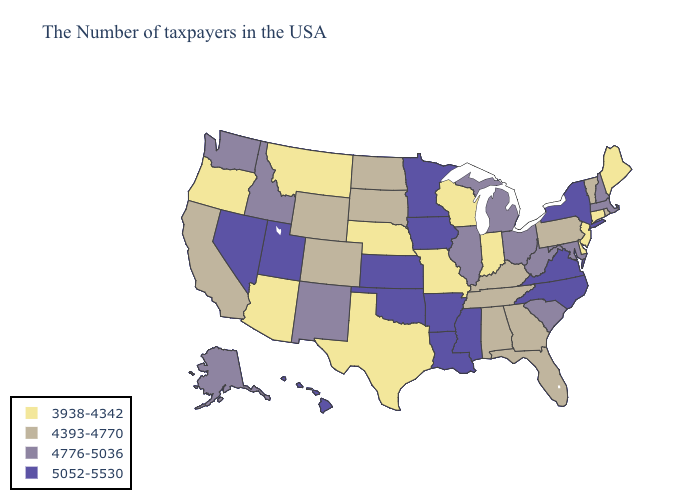What is the lowest value in the MidWest?
Concise answer only. 3938-4342. Does Arizona have the lowest value in the West?
Write a very short answer. Yes. Name the states that have a value in the range 4776-5036?
Concise answer only. Massachusetts, New Hampshire, Maryland, South Carolina, West Virginia, Ohio, Michigan, Illinois, New Mexico, Idaho, Washington, Alaska. Is the legend a continuous bar?
Answer briefly. No. What is the value of Maine?
Be succinct. 3938-4342. What is the value of Ohio?
Short answer required. 4776-5036. What is the value of Arizona?
Concise answer only. 3938-4342. What is the value of South Carolina?
Give a very brief answer. 4776-5036. Does Minnesota have the lowest value in the USA?
Short answer required. No. Which states hav the highest value in the South?
Short answer required. Virginia, North Carolina, Mississippi, Louisiana, Arkansas, Oklahoma. Does Oregon have the lowest value in the West?
Give a very brief answer. Yes. How many symbols are there in the legend?
Keep it brief. 4. How many symbols are there in the legend?
Answer briefly. 4. 